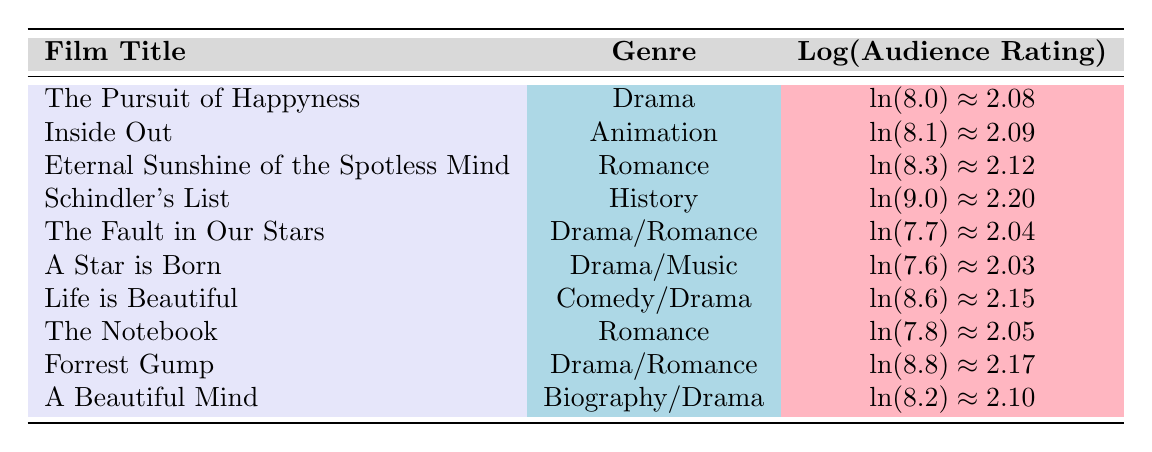What is the audience rating for "Forrest Gump"? The table lists the audience rating for "Forrest Gump" under the related column, which shows it as 8.8.
Answer: 8.8 Which film has the highest audience rating? By reviewing the audience ratings in the table, "Schindler's List" has the highest value at 9.0.
Answer: Schindler's List What is the logarithmic value of the audience rating for "Life is Beautiful"? The table indicates that the logarithmic value for "Life is Beautiful" is approximately 2.15.
Answer: 2.15 What genres are represented in the films with an audience rating higher than 8.0? Filtering films with ratings above 8.0 reveals the genres: Drama, Animation, Romance, History, and Comedy/Drama.
Answer: Drama, Animation, Romance, History, Comedy/Drama Which film has a logarithmic audience rating below 2.05? The films "The Fault in Our Stars" with a rating of approximately 2.04 and "A Star is Born" rated approximately 2.03 both fall below 2.05.
Answer: The Fault in Our Stars, A Star is Born Is the audience rating for "Inside Out" greater than the rating for "The Notebook"? According to the table, "Inside Out" has an audience rating of 8.1, while "The Notebook" has 7.8, verifying that 8.1 > 7.8 is true.
Answer: Yes What is the average audience rating of the films listed in the table? Calculating the average involves summing all audience ratings (8.0 + 8.1 + 8.3 + 9.0 + 7.7 + 7.6 + 8.6 + 7.8 + 8.8 + 8.2 = 80.1) and dividing by 10 (the total number of films), resulting in 80.1 / 10 = 8.01.
Answer: 8.01 How many different genres are found in the table? Analyzing the genre column, all unique genres found are Drama, Animation, Romance, History, Drama/Romance, Drama/Music, Comedy/Drama, and Biography/Drama, totalling to 8 distinct genres.
Answer: 8 Do all films listed have an audience rating above 7.0? The audience ratings show that the lowest rating is 7.6 ("A Star is Born"), thus confirming that every film listed has ratings exceeding 7.0.
Answer: Yes What is the difference in logarithmic values between "Eternal Sunshine of the Spotless Mind" and "Forrest Gump"? The logarithmic value for "Eternal Sunshine of the Spotless Mind" is approximately 2.12, while "Forrest Gump" is approximately 2.17. The difference is 2.17 - 2.12 = 0.05.
Answer: 0.05 